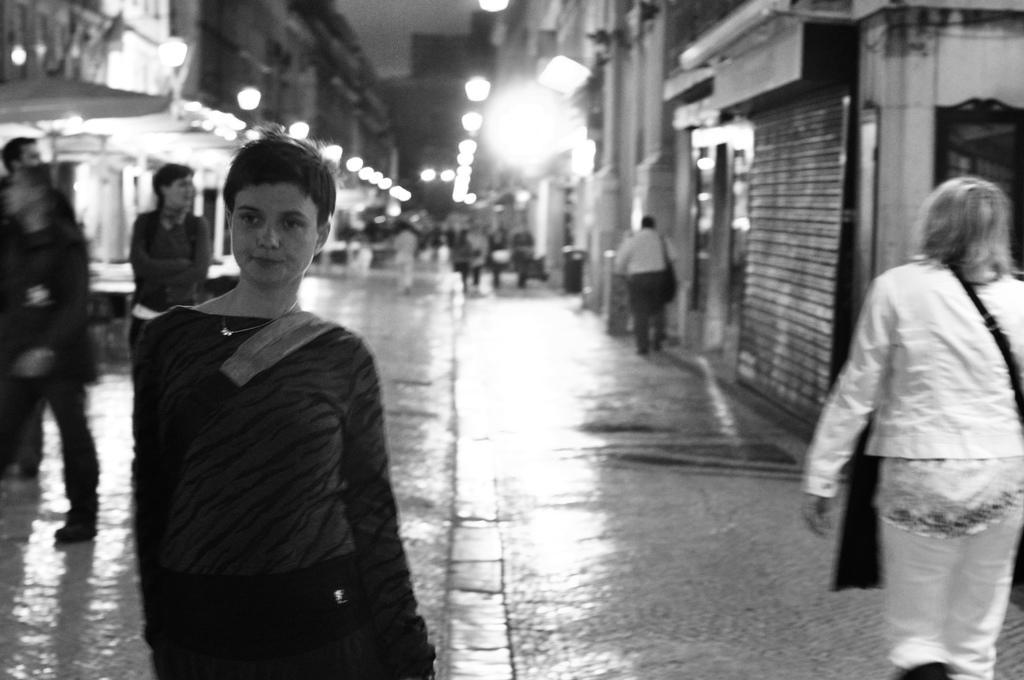Can you describe this image briefly? In this image we can see a black and white picture of a group of people standing on the ground. On the left and right side of the image we can see buildings and some lights. At the top of the image we can see the sky. 